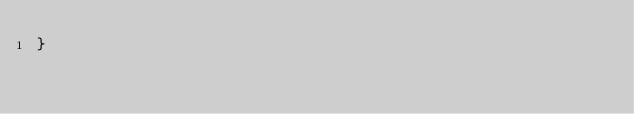Convert code to text. <code><loc_0><loc_0><loc_500><loc_500><_Kotlin_>}
</code> 